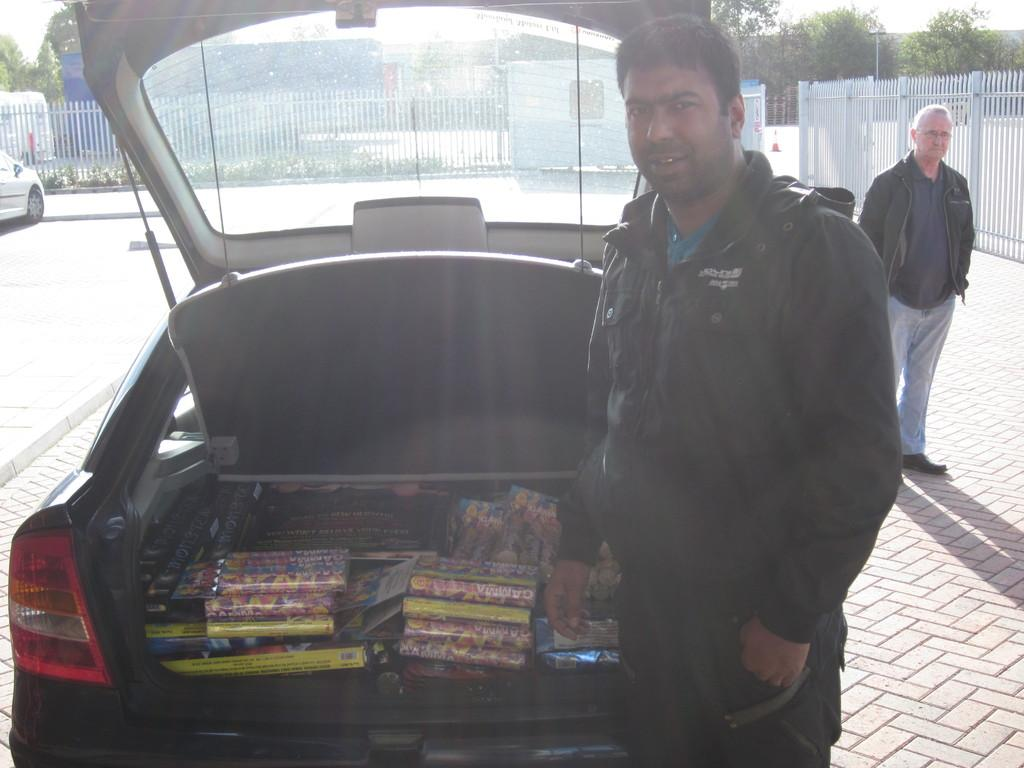What are the people in the image doing? The people in the image are standing on the ground. What else can be seen on the ground in the image? There are cars parked on the ground in the image. What is inside the cars that are parked? Packets are kept in the car dicky. What can be seen in the distance in the image? There are trees visible in the background of the image. What type of chicken is being cooked on the match in the image? There is no chicken or match present in the image; it features people standing on the ground and cars parked on the ground with packets in the car dicky. 